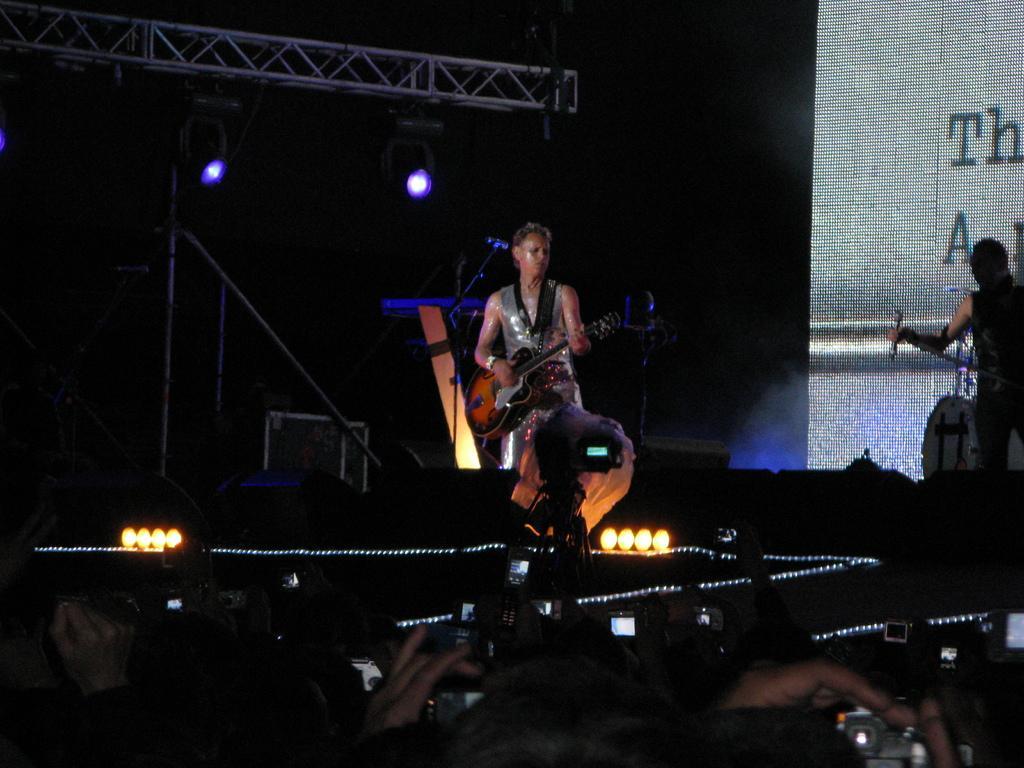How would you summarize this image in a sentence or two? In this image there is a woman standing and playing a guitar and in back ground there is camera, screen, focus lights , iron rods. 